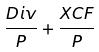<formula> <loc_0><loc_0><loc_500><loc_500>\frac { D i v } { P } + \frac { X C F } { P }</formula> 